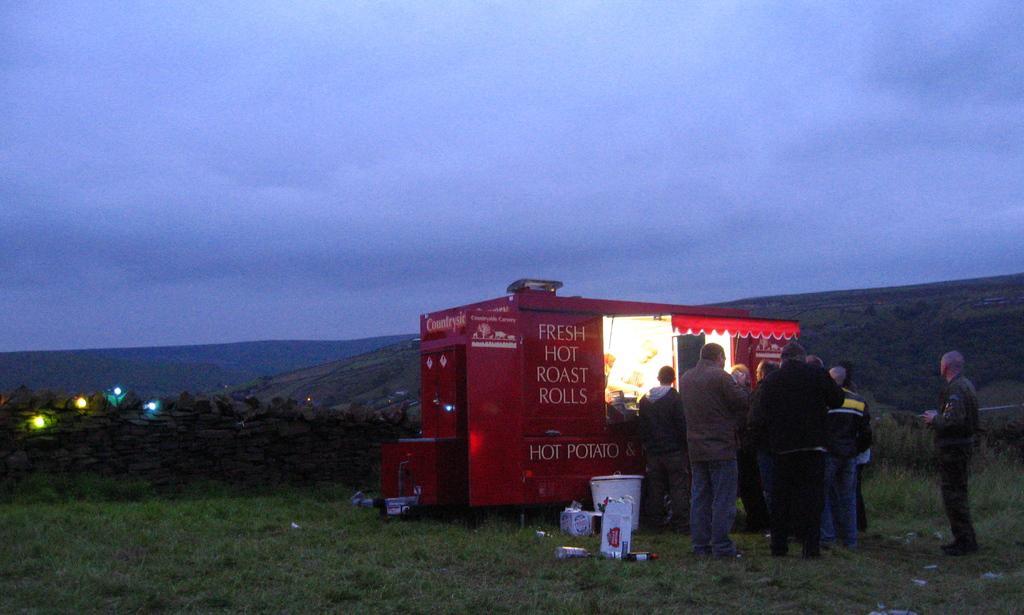How would you summarize this image in a sentence or two? In this image I can see some grass, few persons standing, a small shed which is red in color and few other objects on the ground. I can see few lights and a wall which is made of rocks. In the background I can see few mountains and the sky. 